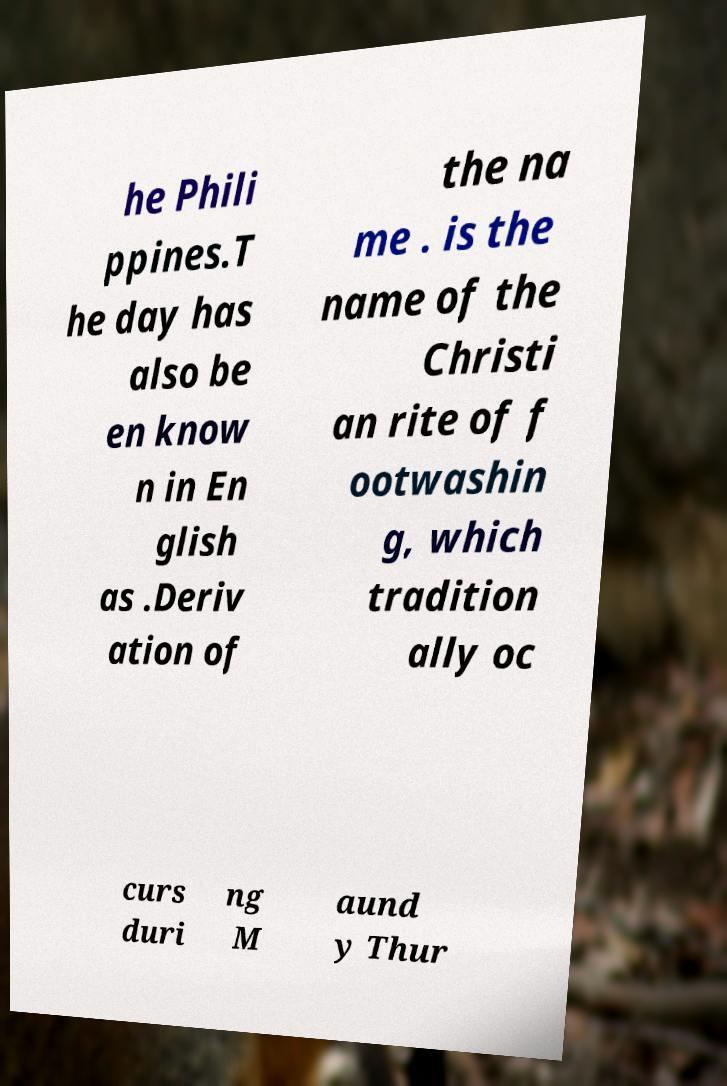I need the written content from this picture converted into text. Can you do that? he Phili ppines.T he day has also be en know n in En glish as .Deriv ation of the na me . is the name of the Christi an rite of f ootwashin g, which tradition ally oc curs duri ng M aund y Thur 